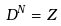<formula> <loc_0><loc_0><loc_500><loc_500>D ^ { N } = Z</formula> 